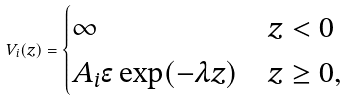<formula> <loc_0><loc_0><loc_500><loc_500>V _ { i } ( z ) = \begin{cases} \infty & z < 0 \\ A _ { i } \epsilon \exp ( - \lambda z ) & z \geq 0 , \end{cases}</formula> 